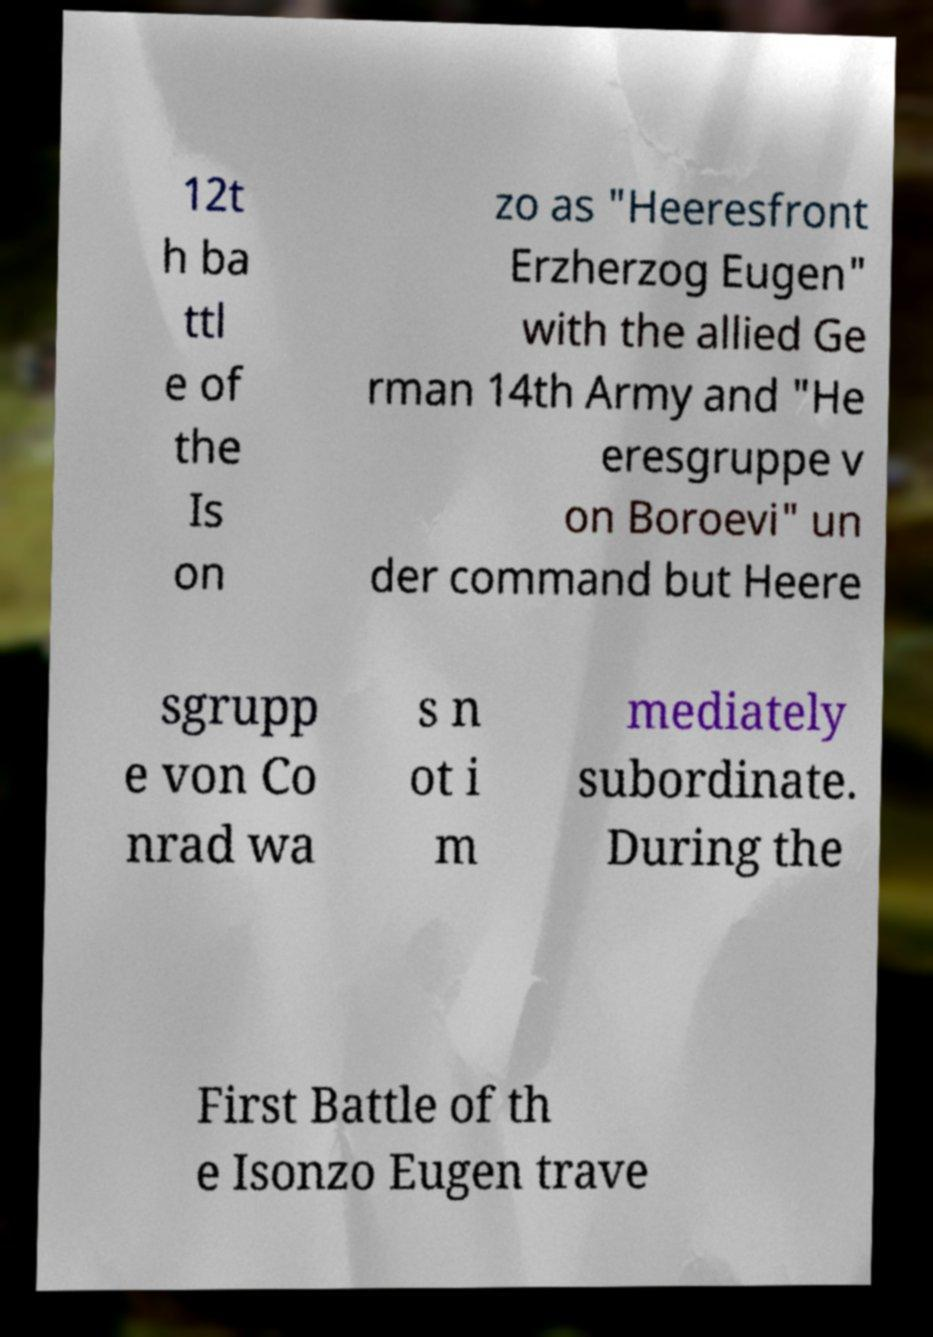Could you assist in decoding the text presented in this image and type it out clearly? 12t h ba ttl e of the Is on zo as "Heeresfront Erzherzog Eugen" with the allied Ge rman 14th Army and "He eresgruppe v on Boroevi" un der command but Heere sgrupp e von Co nrad wa s n ot i m mediately subordinate. During the First Battle of th e Isonzo Eugen trave 